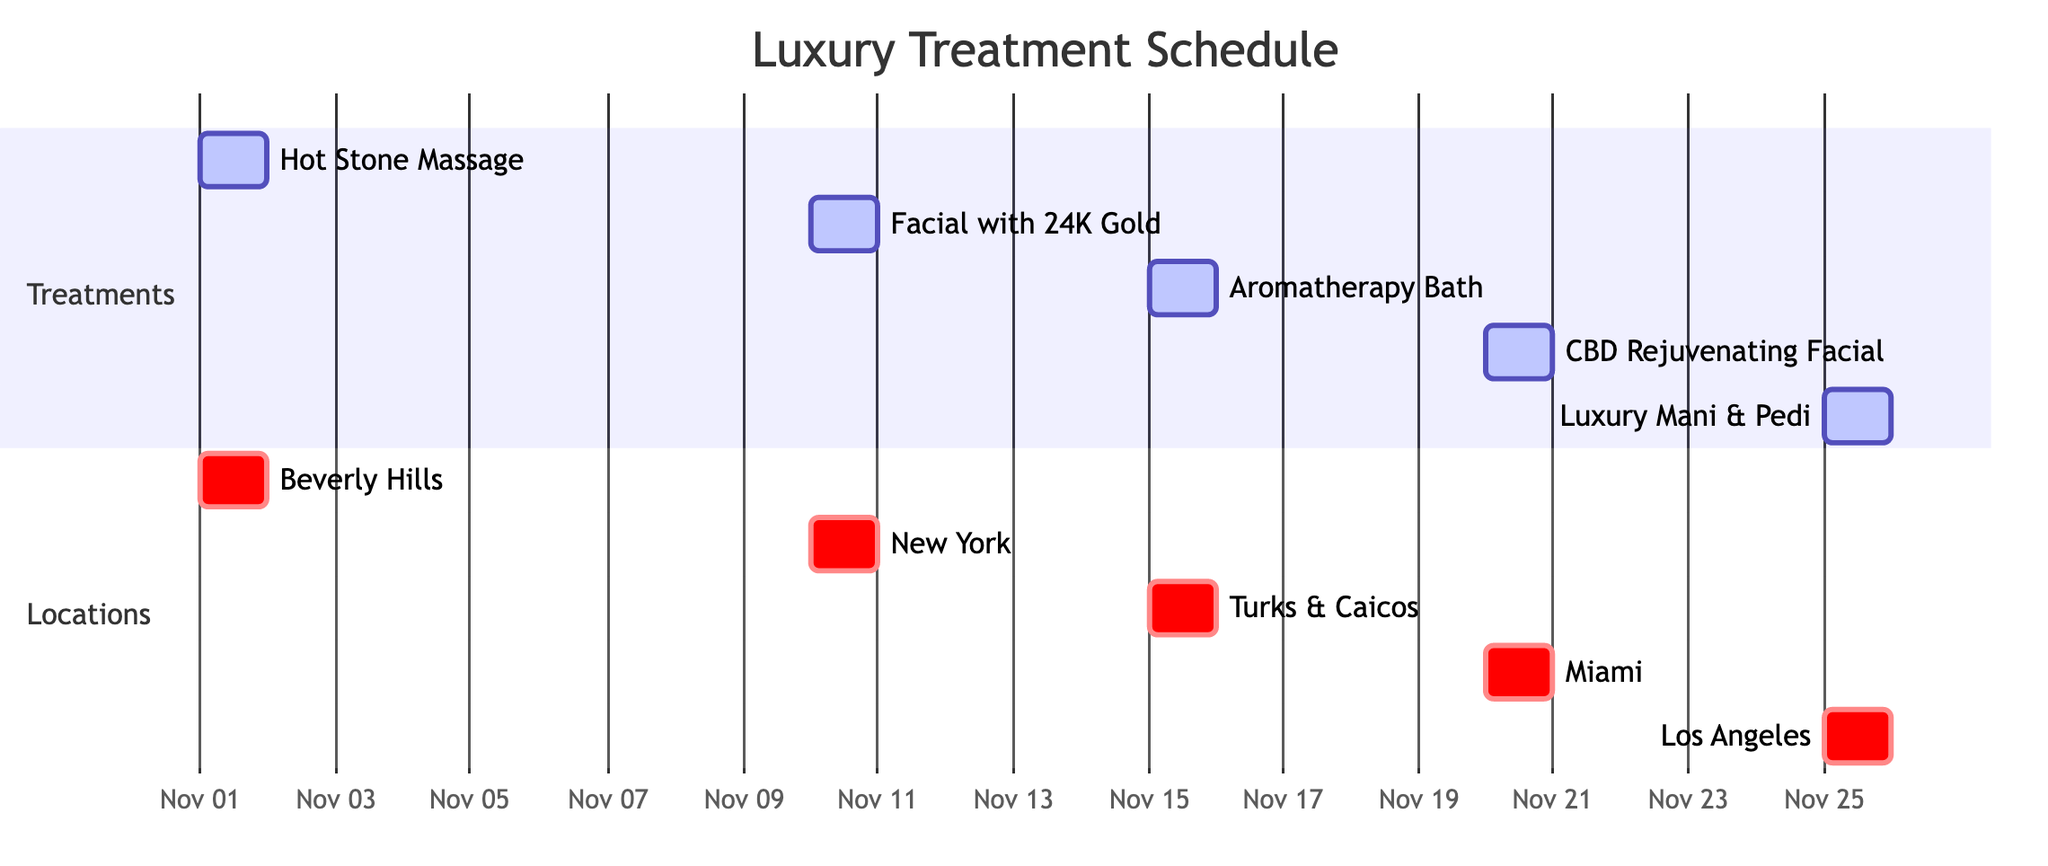What is the first treatment scheduled? The first treatment listed on the Gantt chart is "Hot Stone Massage," which has a start date of November 1, 2023.
Answer: Hot Stone Massage How many treatments are scheduled in total? By counting each unique treatment listed in the "Treatments" section of the Gantt chart, there are five treatments planned.
Answer: 5 Which treatment is taking place on November 10, 2023? The Gantt chart shows that "Facial with 24K Gold" is scheduled for November 10, 2023.
Answer: Facial with 24K Gold What is the location for the Aromatherapy Bath Experience? Under the "Locations" section in the Gantt chart, the treatment "Aromatherapy Bath Experience" is associated with the location "Aman Spa, Turks and Caicos."
Answer: Aman Spa, Turks and Caicos Which treatment comes last in the schedule? The last treatment in the schedule is "Luxury Manicure & Pedicure," scheduled for November 25, 2023.
Answer: Luxury Manicure & Pedicure How many treatments are scheduled in Miami? There is one treatment scheduled in Miami, which is the "Rejuvenating Facial with CBD" on November 20, 2023.
Answer: 1 What location is associated with the treatment on November 1? The treatment scheduled for November 1 is "Hot Stone Massage," and it takes place at "The Spa at The Four Seasons, Beverly Hills."
Answer: The Spa at The Four Seasons, Beverly Hills Which treatment is offered at SkinCamp? The treatment scheduled at SkinCamp in New York is "Facial with 24K Gold."
Answer: Facial with 24K Gold How many days is the interval between the Facial with 24K Gold and the Aromatherapy Bath Experience? The Facial with 24K Gold is on November 10, and the Aromatherapy Bath Experience is on November 15, which is a 5-day interval.
Answer: 5 days 